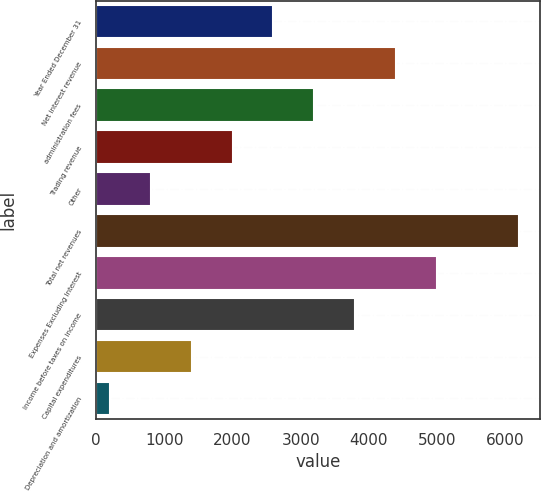Convert chart to OTSL. <chart><loc_0><loc_0><loc_500><loc_500><bar_chart><fcel>Year Ended December 31<fcel>Net interest revenue<fcel>administration fees<fcel>Trading revenue<fcel>Other<fcel>Total net revenues<fcel>Expenses Excluding Interest<fcel>Income before taxes on income<fcel>Capital expenditures<fcel>Depreciation and amortization<nl><fcel>2601.8<fcel>4400.9<fcel>3201.5<fcel>2002.1<fcel>802.7<fcel>6200<fcel>5000.6<fcel>3801.2<fcel>1402.4<fcel>203<nl></chart> 